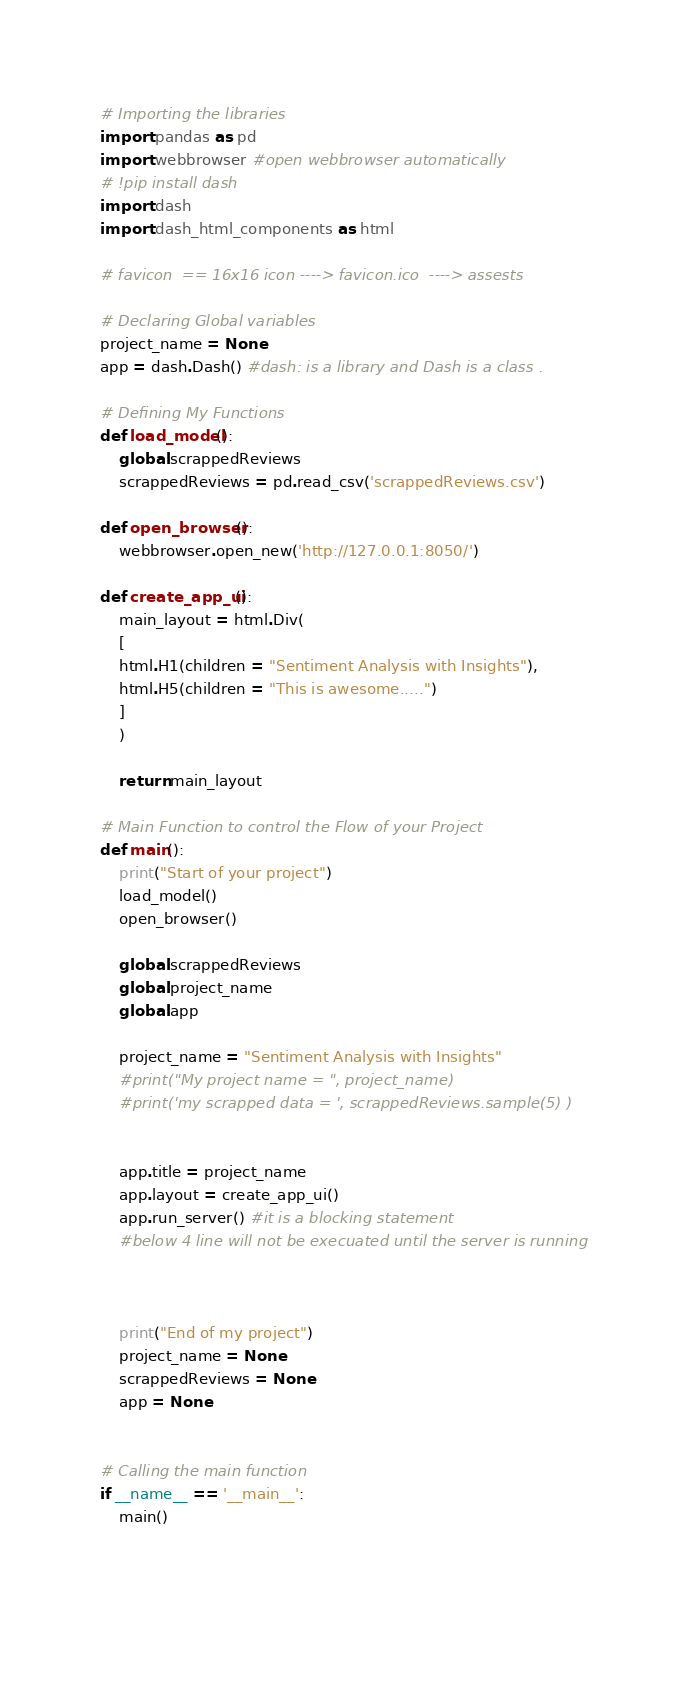<code> <loc_0><loc_0><loc_500><loc_500><_Python_># Importing the libraries
import pandas as pd
import webbrowser #open webbrowser automatically 
# !pip install dash
import dash
import dash_html_components as html

# favicon  == 16x16 icon ----> favicon.ico  ----> assests

# Declaring Global variables
project_name = None
app = dash.Dash() #dash: is a library and Dash is a class .

# Defining My Functions
def load_model():
    global scrappedReviews
    scrappedReviews = pd.read_csv('scrappedReviews.csv')

def open_browser():
    webbrowser.open_new('http://127.0.0.1:8050/')
    
def create_app_ui():
    main_layout = html.Div(
    [
    html.H1(children = "Sentiment Analysis with Insights"),
    html.H5(children = "This is awesome.....")
    ]    
    )
    
    return main_layout

# Main Function to control the Flow of your Project
def main():
    print("Start of your project")
    load_model()
    open_browser()
    
    global scrappedReviews
    global project_name
    global app
    
    project_name = "Sentiment Analysis with Insights"
    #print("My project name = ", project_name)
    #print('my scrapped data = ', scrappedReviews.sample(5) )
    
    
    app.title = project_name
    app.layout = create_app_ui()
    app.run_server() #it is a blocking statement 
    #below 4 line will not be execuated until the server is running
    
    
    
    print("End of my project")
    project_name = None
    scrappedReviews = None
    app = None
    
        
# Calling the main function 
if __name__ == '__main__':
    main()
    
    
    </code> 